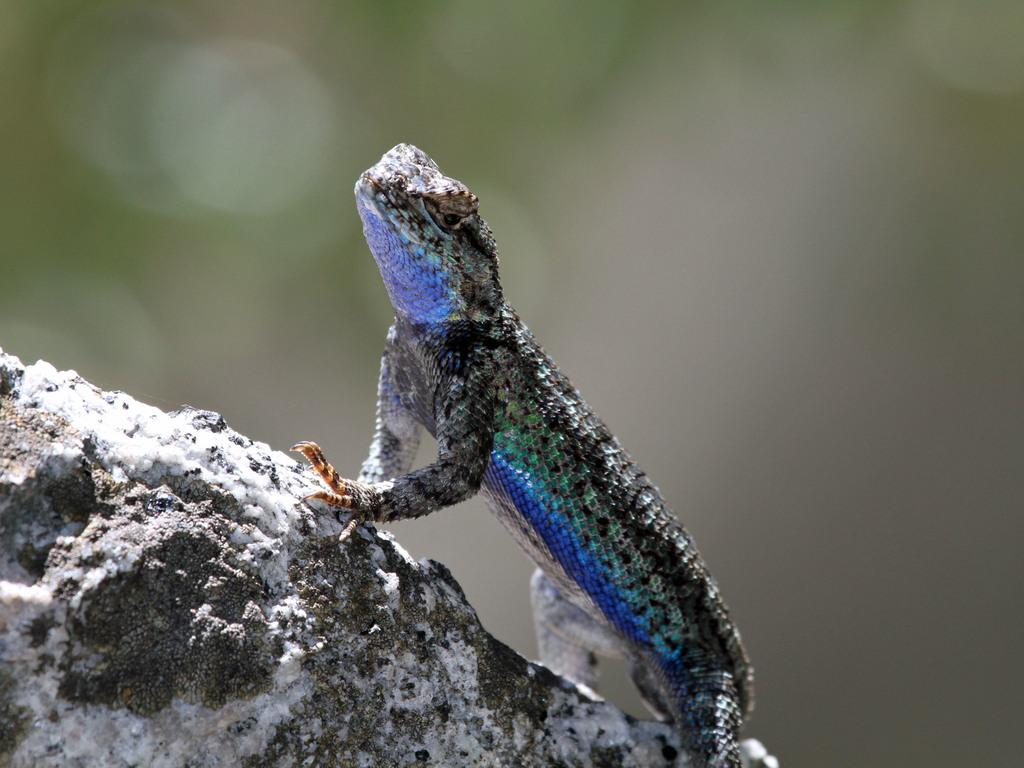What type of animal is in the image? There is a lizard in the image. What surface is the lizard on? The lizard is on a stone. Can you describe the background of the image? The background of the image is blurred. How many bikes can be seen in the image? There are no bikes present in the image. What is the value of the cent in the image? There is no cent or any monetary unit present in the image. 